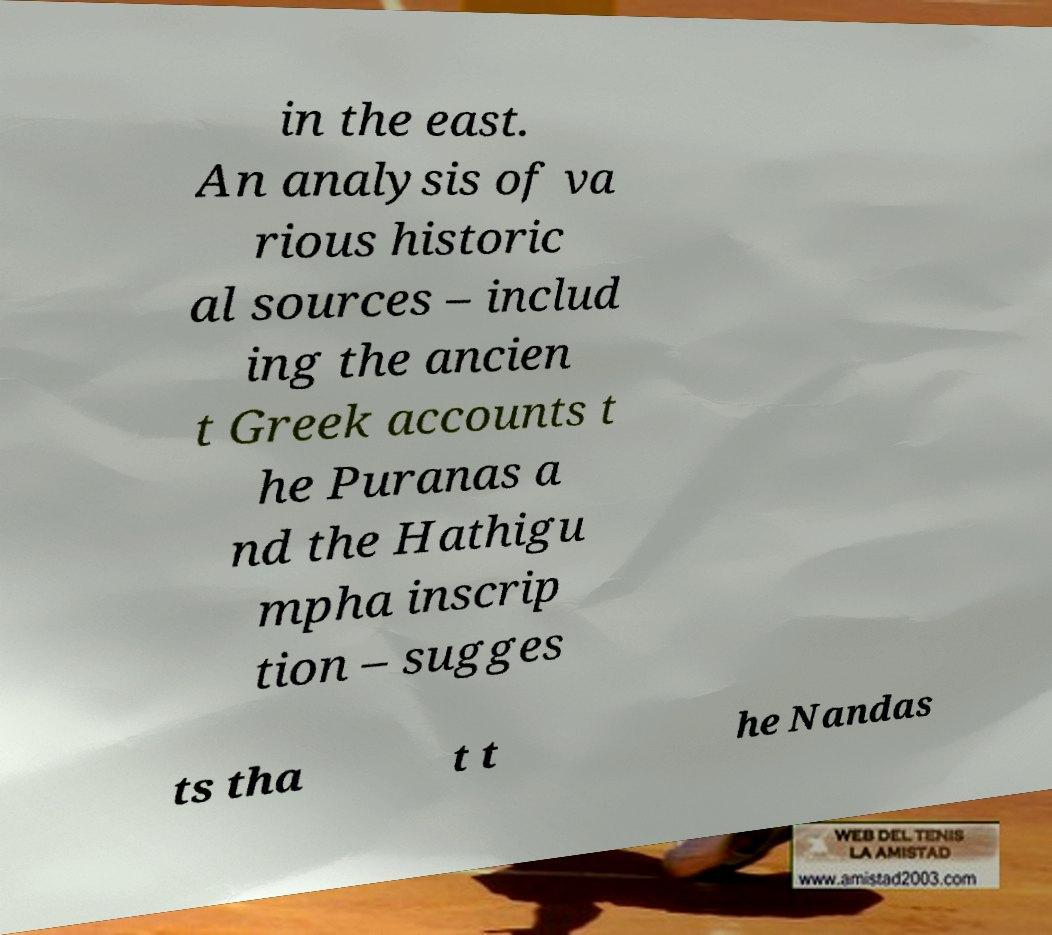Please read and relay the text visible in this image. What does it say? in the east. An analysis of va rious historic al sources – includ ing the ancien t Greek accounts t he Puranas a nd the Hathigu mpha inscrip tion – sugges ts tha t t he Nandas 